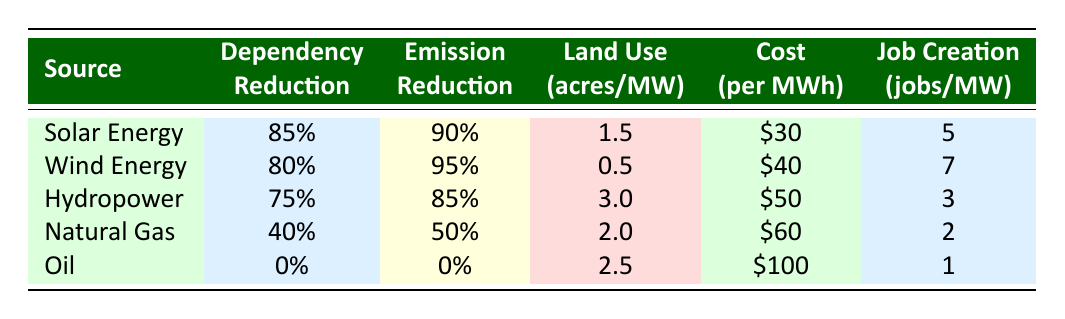What is the dependency reduction percentage for solar energy? The table lists solar energy under the source category. In the dependency reduction column adjacent to it, the value is shown as 85%.
Answer: 85% Which energy source has the highest emission reduction percentage? By examining the emission reduction column, wind energy has the highest value listed at 95%.
Answer: Wind Energy What is the average cost per MWh of natural gas and oil? The cost per MWh for natural gas is $60 and for oil it is $100. Adding these values gives $160, and dividing by 2 provides the average cost: $160/2 = $80.
Answer: $80 True or False: Hydropower has a dependency reduction greater than natural gas. The dependency reduction for hydropower is 75%, while for natural gas it is 40%. Since 75% is greater than 40%, the statement is true.
Answer: True How many jobs are created per MW on average across all the renewable energy sources? The job creations are 5 for solar, 7 for wind, and 3 for hydropower. Adding these gives 15 jobs, then dividing by the 3 sources gives an average of 5 jobs per MW: 15/3 = 5.
Answer: 5 